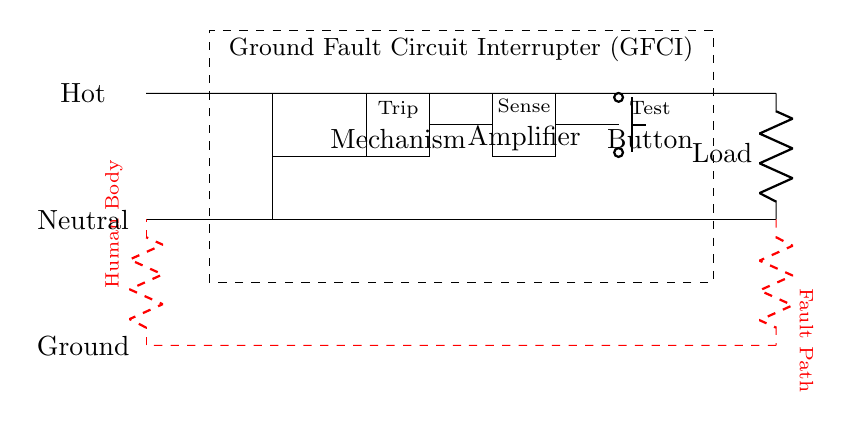What component is used for detecting ground faults? The component used for detecting ground faults is the Sense Amplifier, which is specifically designed to monitor current levels and identify imbalance conditions.
Answer: Sense Amplifier What is the purpose of the Test Button in this circuit? The Test Button is used to simulate a ground fault condition to check if the GFCI is functioning correctly by interrupting the circuit.
Answer: Test Button How many main components are in the GFCI? There are three main components in the GFCI: the Trip Mechanism, the Sense Amplifier, and the Test Button.
Answer: Three What symbol indicates that this is a transformer in the circuit? The transformer is represented by the transformer core symbol, which looks like two coils placed alongside each other.
Answer: Transformer core symbol What is the significance of the red dashed path in the circuit? The red dashed path signifies the potential fault path that current might take through a human body in the event of a ground fault, highlighting the danger of electrical shock.
Answer: Fault Path Which connection types are indicated for the circuits? The circuit indicates three types of connections: Hot, Neutral, and Ground, each labeled accordingly in the diagram for clarity.
Answer: Hot, Neutral, Ground 